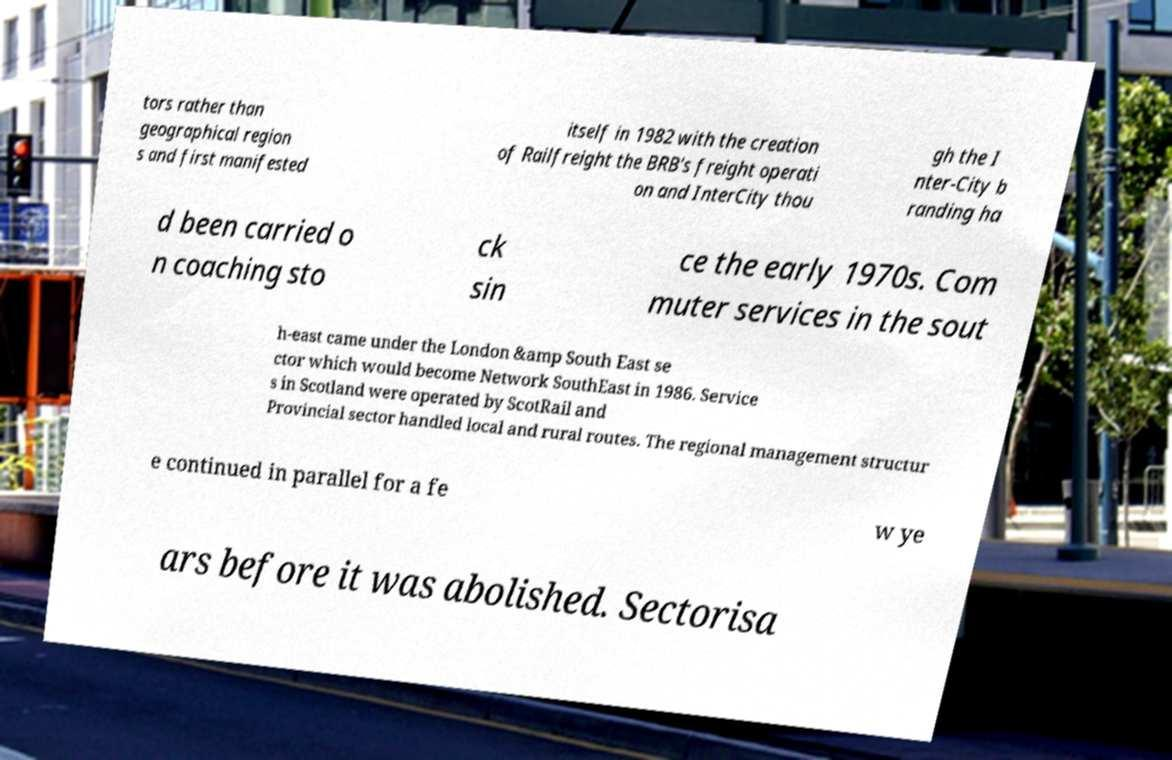Can you read and provide the text displayed in the image?This photo seems to have some interesting text. Can you extract and type it out for me? tors rather than geographical region s and first manifested itself in 1982 with the creation of Railfreight the BRB's freight operati on and InterCity thou gh the I nter-City b randing ha d been carried o n coaching sto ck sin ce the early 1970s. Com muter services in the sout h-east came under the London &amp South East se ctor which would become Network SouthEast in 1986. Service s in Scotland were operated by ScotRail and Provincial sector handled local and rural routes. The regional management structur e continued in parallel for a fe w ye ars before it was abolished. Sectorisa 